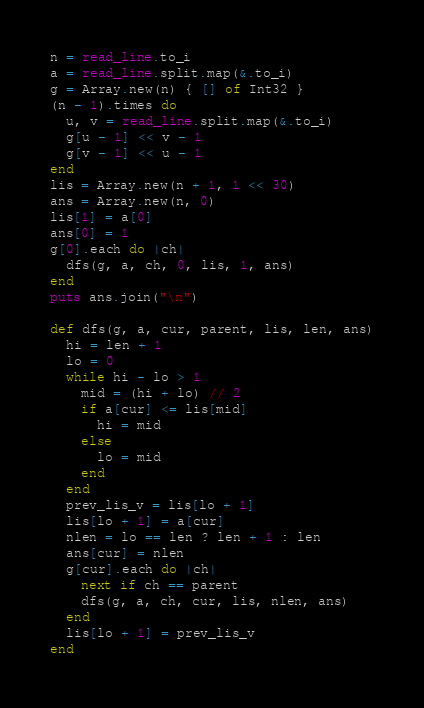<code> <loc_0><loc_0><loc_500><loc_500><_Crystal_>n = read_line.to_i
a = read_line.split.map(&.to_i)
g = Array.new(n) { [] of Int32 }
(n - 1).times do
  u, v = read_line.split.map(&.to_i)
  g[u - 1] << v - 1
  g[v - 1] << u - 1
end
lis = Array.new(n + 1, 1 << 30)
ans = Array.new(n, 0)
lis[1] = a[0]
ans[0] = 1
g[0].each do |ch|
  dfs(g, a, ch, 0, lis, 1, ans)
end
puts ans.join("\n")

def dfs(g, a, cur, parent, lis, len, ans)
  hi = len + 1
  lo = 0
  while hi - lo > 1
    mid = (hi + lo) // 2
    if a[cur] <= lis[mid]
      hi = mid
    else
      lo = mid
    end
  end
  prev_lis_v = lis[lo + 1]
  lis[lo + 1] = a[cur]
  nlen = lo == len ? len + 1 : len
  ans[cur] = nlen
  g[cur].each do |ch|
    next if ch == parent
    dfs(g, a, ch, cur, lis, nlen, ans)
  end
  lis[lo + 1] = prev_lis_v
end
</code> 